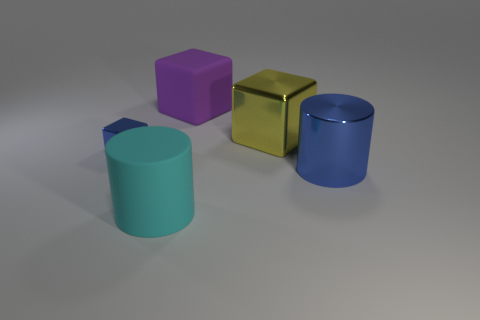There is a blue metallic thing that is in front of the shiny cube that is left of the large matte cube; how many cyan matte objects are behind it?
Keep it short and to the point. 0. What size is the metal cylinder that is the same color as the small metallic cube?
Your answer should be compact. Large. Is there a blue cylinder made of the same material as the tiny blue thing?
Your answer should be compact. Yes. Is the small blue cube made of the same material as the purple thing?
Your response must be concise. No. How many large purple rubber blocks are to the right of the blue shiny thing that is left of the big blue cylinder?
Offer a very short reply. 1. What number of purple things are either big cylinders or big objects?
Provide a succinct answer. 1. The big metallic object that is in front of the blue thing that is behind the blue metal thing to the right of the matte cylinder is what shape?
Provide a succinct answer. Cylinder. There is another metal thing that is the same size as the yellow metal object; what is its color?
Your answer should be very brief. Blue. What number of other small objects have the same shape as the purple matte thing?
Your response must be concise. 1. There is a yellow thing; is it the same size as the rubber object behind the blue metal cube?
Offer a terse response. Yes. 